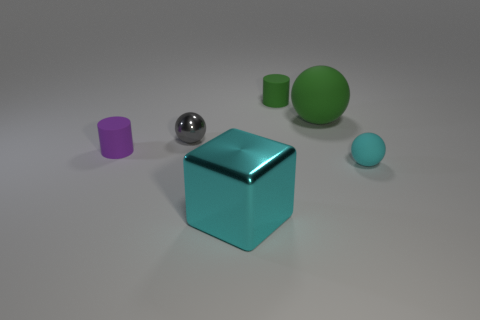Subtract all tiny cyan spheres. How many spheres are left? 2 Add 2 cyan spheres. How many objects exist? 8 Subtract all gray spheres. How many spheres are left? 2 Subtract 1 cyan cubes. How many objects are left? 5 Subtract all cylinders. How many objects are left? 4 Subtract 3 balls. How many balls are left? 0 Subtract all red cylinders. Subtract all yellow cubes. How many cylinders are left? 2 Subtract all green spheres. How many blue blocks are left? 0 Subtract all large green rubber objects. Subtract all cubes. How many objects are left? 4 Add 3 gray metallic things. How many gray metallic things are left? 4 